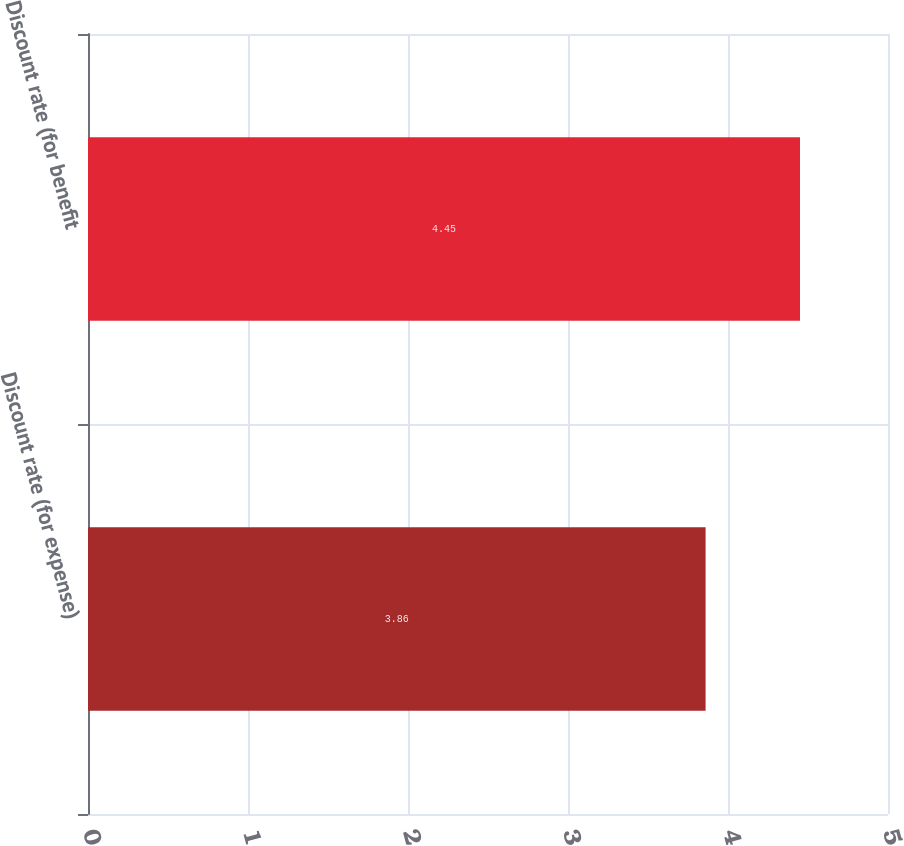Convert chart. <chart><loc_0><loc_0><loc_500><loc_500><bar_chart><fcel>Discount rate (for expense)<fcel>Discount rate (for benefit<nl><fcel>3.86<fcel>4.45<nl></chart> 